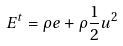<formula> <loc_0><loc_0><loc_500><loc_500>E ^ { t } = \rho e + \rho \frac { 1 } { 2 } u ^ { 2 }</formula> 